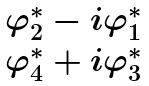<formula> <loc_0><loc_0><loc_500><loc_500>\begin{array} { c } { { \varphi _ { 2 } ^ { * } - i \varphi _ { 1 } ^ { * } } } \\ { { \varphi _ { 4 } ^ { * } + i \varphi _ { 3 } ^ { * } } } \end{array}</formula> 